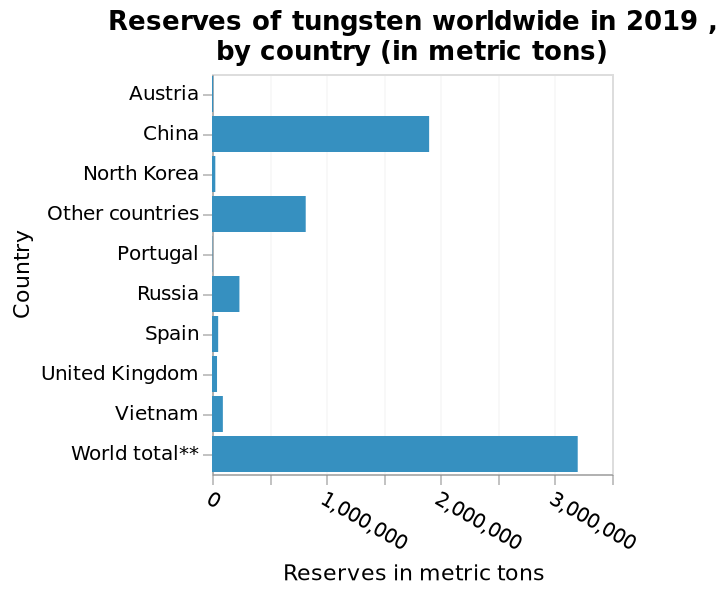<image>
What is the maximum value shown on the x-axis of the bar diagram?  The maximum value shown on the x-axis is 3,500,000 metric tons. Which country has the most works worldwide?  China has the most works worldwide. 